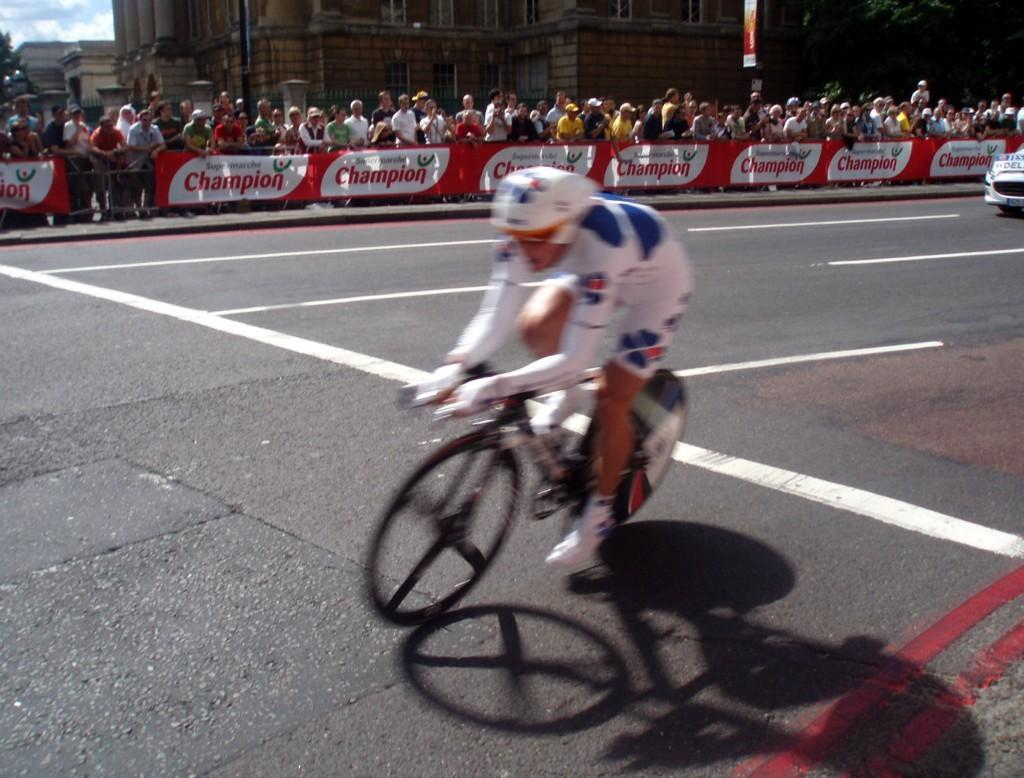What is the man in the image doing? The man is riding a bicycle in the image. Can you describe any other vehicles in the image? There is at least one other vehicle in the image. What can be seen in the background of the image? Many people, trees, and buildings are visible in the background of the image. Where is the mother standing with the chickens in the image? There is no mother or chickens present in the image. 